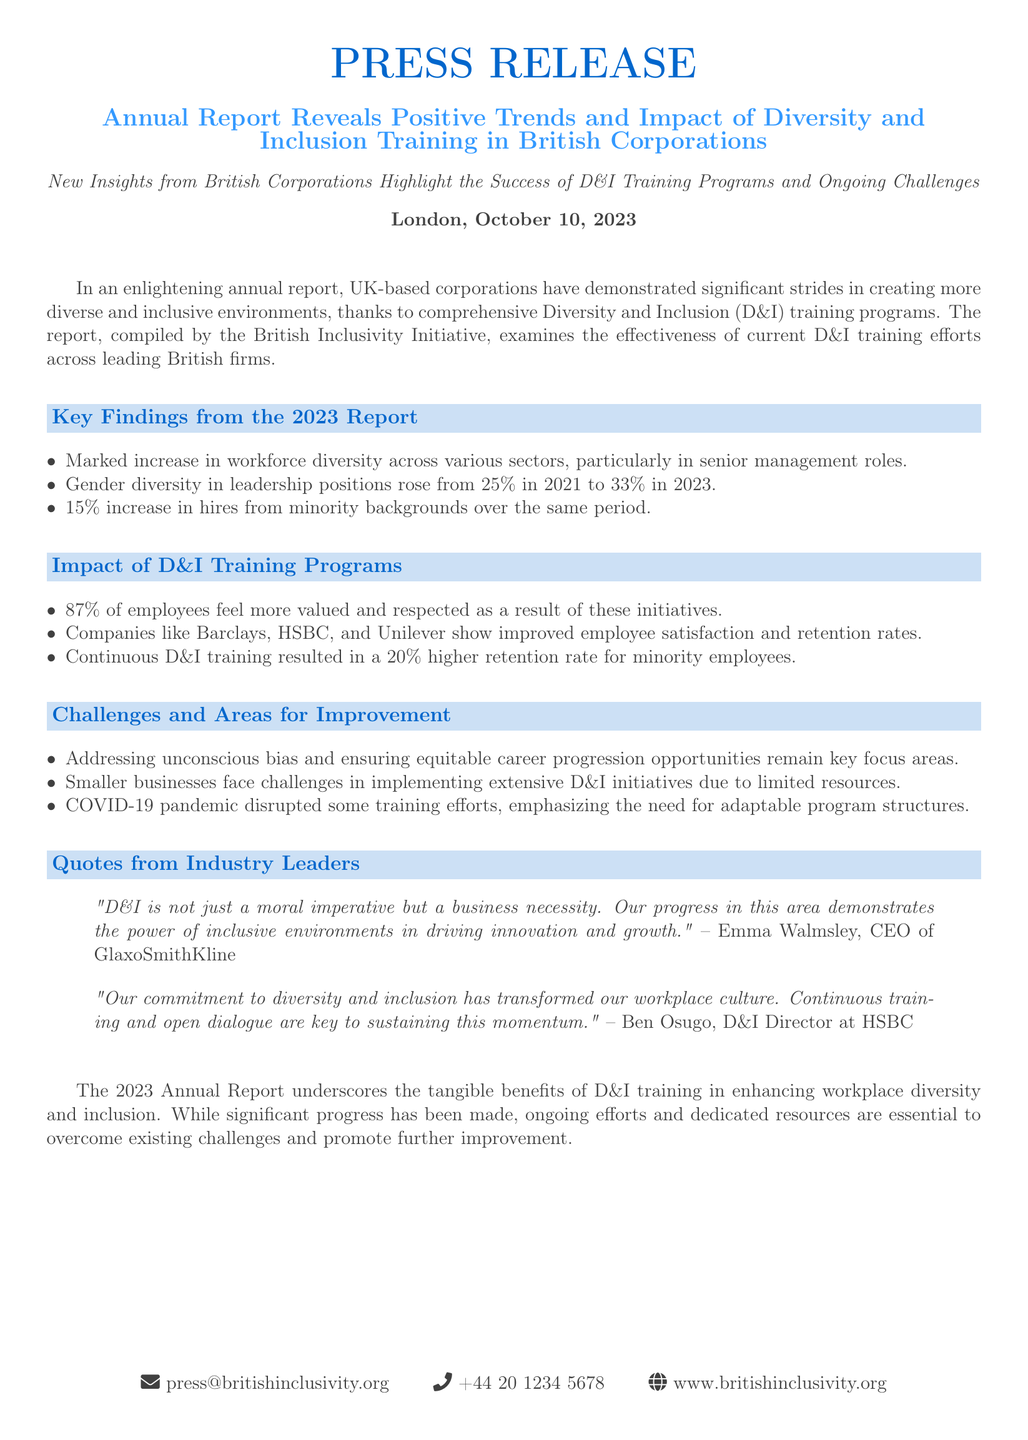What is the percentage increase in gender diversity in leadership positions from 2021 to 2023? The report states that gender diversity in leadership positions rose from 25% in 2021 to 33% in 2023, which is an 8% increase.
Answer: 8% What organization compiled the report? The report is compiled by the British Inclusivity Initiative, which is mentioned in the introduction.
Answer: British Inclusivity Initiative What percentage of employees feel more valued due to D&I initiatives? The document specifies that 87% of employees feel more valued and respected as a result of these initiatives.
Answer: 87% Which companies showed improved employee satisfaction and retention rates? The report highlights companies like Barclays, HSBC, and Unilever as examples of firms with improved metrics.
Answer: Barclays, HSBC, Unilever What are the key focus areas for improvement in D&I? The challenges highlighted include addressing unconscious bias and ensuring equitable career progression opportunities.
Answer: Unconscious bias and career progression In what year was the annual report published? The document states the report was published on October 10, 2023.
Answer: October 10, 2023 What was the increase in hires from minority backgrounds during the reported period? The report indicates a 15% increase in hires from minority backgrounds from 2021 to 2023.
Answer: 15% Who is the CEO of GlaxoSmithKline quoted in the report? The report quotes Emma Walmsley, who is the CEO of GlaxoSmithKline.
Answer: Emma Walmsley What is emphasized as a need due to the disruption caused by the COVID-19 pandemic? The document emphasizes the need for adaptable program structures in light of the disruptions caused by the pandemic.
Answer: Adaptable program structures 